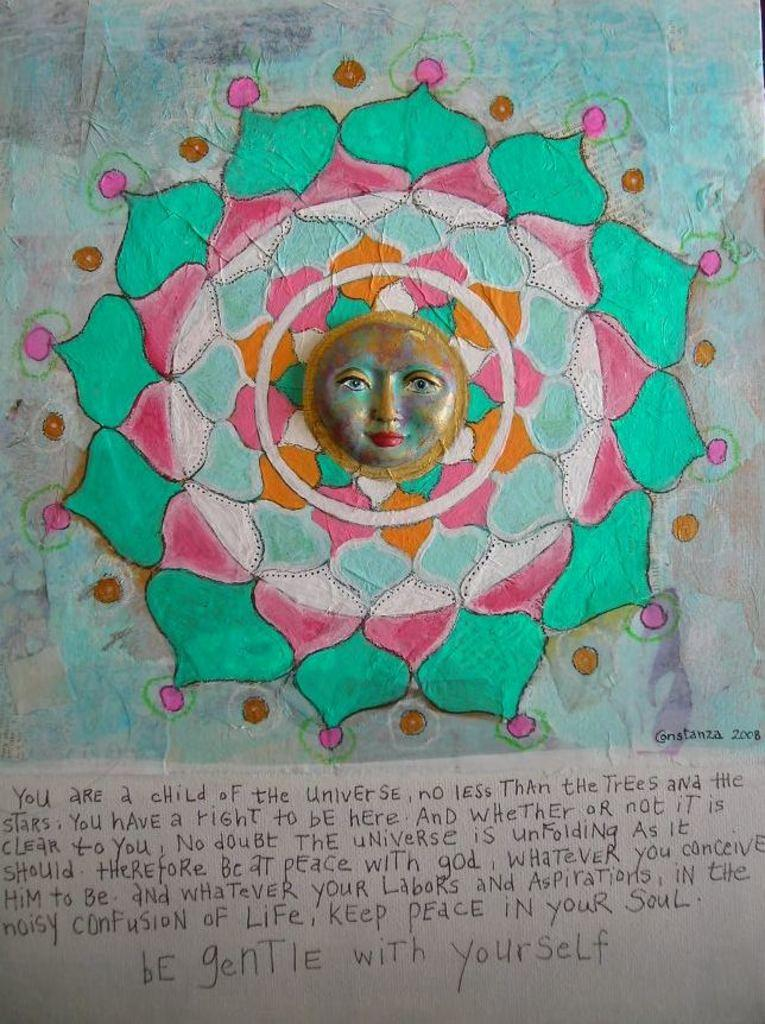What is depicted on the piece of paper in the image? There is a drawing of the sun on a piece of paper. What else can be seen on the paper? There are notes beneath the drawing. What type of verse is written on the paper in the image? There is no verse present in the image; it features a drawing of the sun and notes beneath it. What is the size of the letters in the notes? The size of the letters in the notes cannot be determined from the image alone, as the image's resolution may not be high enough to accurately assess the letter size. 